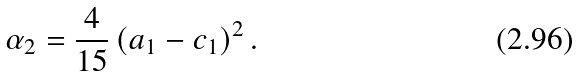Convert formula to latex. <formula><loc_0><loc_0><loc_500><loc_500>\alpha _ { 2 } = \frac { 4 } { 1 5 } \left ( a _ { 1 } - c _ { 1 } \right ) ^ { 2 } .</formula> 